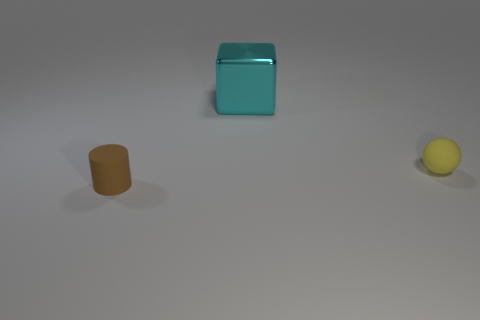What shape is the other thing that is the same material as the small yellow thing?
Provide a succinct answer. Cylinder. Does the yellow ball that is behind the tiny brown cylinder have the same material as the cylinder?
Keep it short and to the point. Yes. How many other objects are the same material as the small sphere?
Provide a succinct answer. 1. What number of things are things in front of the large thing or small matte objects that are left of the large cyan metallic cube?
Your answer should be very brief. 2. Is the shape of the small thing to the left of the small ball the same as the tiny matte thing behind the small brown matte cylinder?
Your answer should be compact. No. There is another rubber object that is the same size as the yellow rubber thing; what shape is it?
Ensure brevity in your answer.  Cylinder. How many shiny objects are either tiny brown cylinders or gray blocks?
Provide a short and direct response. 0. Is the small thing that is in front of the ball made of the same material as the yellow object on the right side of the small cylinder?
Provide a succinct answer. Yes. There is a cylinder that is the same material as the sphere; what is its color?
Keep it short and to the point. Brown. Are there more yellow balls that are behind the brown rubber cylinder than matte cylinders to the right of the large shiny thing?
Offer a terse response. Yes. 